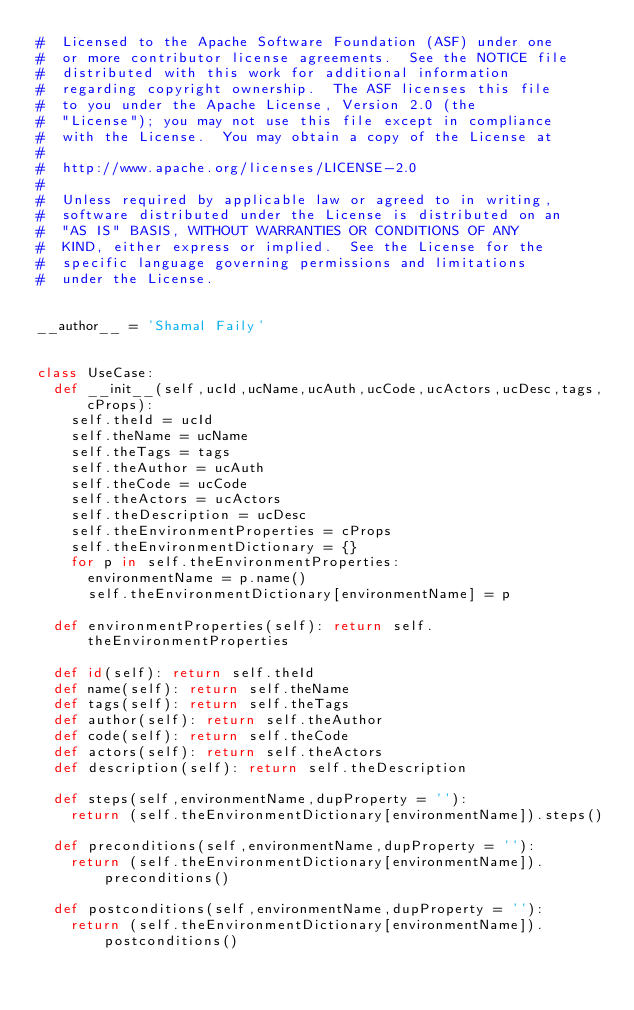Convert code to text. <code><loc_0><loc_0><loc_500><loc_500><_Python_>#  Licensed to the Apache Software Foundation (ASF) under one
#  or more contributor license agreements.  See the NOTICE file
#  distributed with this work for additional information
#  regarding copyright ownership.  The ASF licenses this file
#  to you under the Apache License, Version 2.0 (the
#  "License"); you may not use this file except in compliance
#  with the License.  You may obtain a copy of the License at
#
#  http://www.apache.org/licenses/LICENSE-2.0
#
#  Unless required by applicable law or agreed to in writing,
#  software distributed under the License is distributed on an
#  "AS IS" BASIS, WITHOUT WARRANTIES OR CONDITIONS OF ANY
#  KIND, either express or implied.  See the License for the
#  specific language governing permissions and limitations
#  under the License.


__author__ = 'Shamal Faily'


class UseCase:
  def __init__(self,ucId,ucName,ucAuth,ucCode,ucActors,ucDesc,tags,cProps):
    self.theId = ucId
    self.theName = ucName
    self.theTags = tags
    self.theAuthor = ucAuth
    self.theCode = ucCode
    self.theActors = ucActors
    self.theDescription = ucDesc
    self.theEnvironmentProperties = cProps
    self.theEnvironmentDictionary = {}
    for p in self.theEnvironmentProperties:
      environmentName = p.name()
      self.theEnvironmentDictionary[environmentName] = p

  def environmentProperties(self): return self.theEnvironmentProperties

  def id(self): return self.theId
  def name(self): return self.theName
  def tags(self): return self.theTags
  def author(self): return self.theAuthor
  def code(self): return self.theCode
  def actors(self): return self.theActors
  def description(self): return self.theDescription

  def steps(self,environmentName,dupProperty = ''):
    return (self.theEnvironmentDictionary[environmentName]).steps()

  def preconditions(self,environmentName,dupProperty = ''):
    return (self.theEnvironmentDictionary[environmentName]).preconditions()

  def postconditions(self,environmentName,dupProperty = ''):
    return (self.theEnvironmentDictionary[environmentName]).postconditions()
</code> 